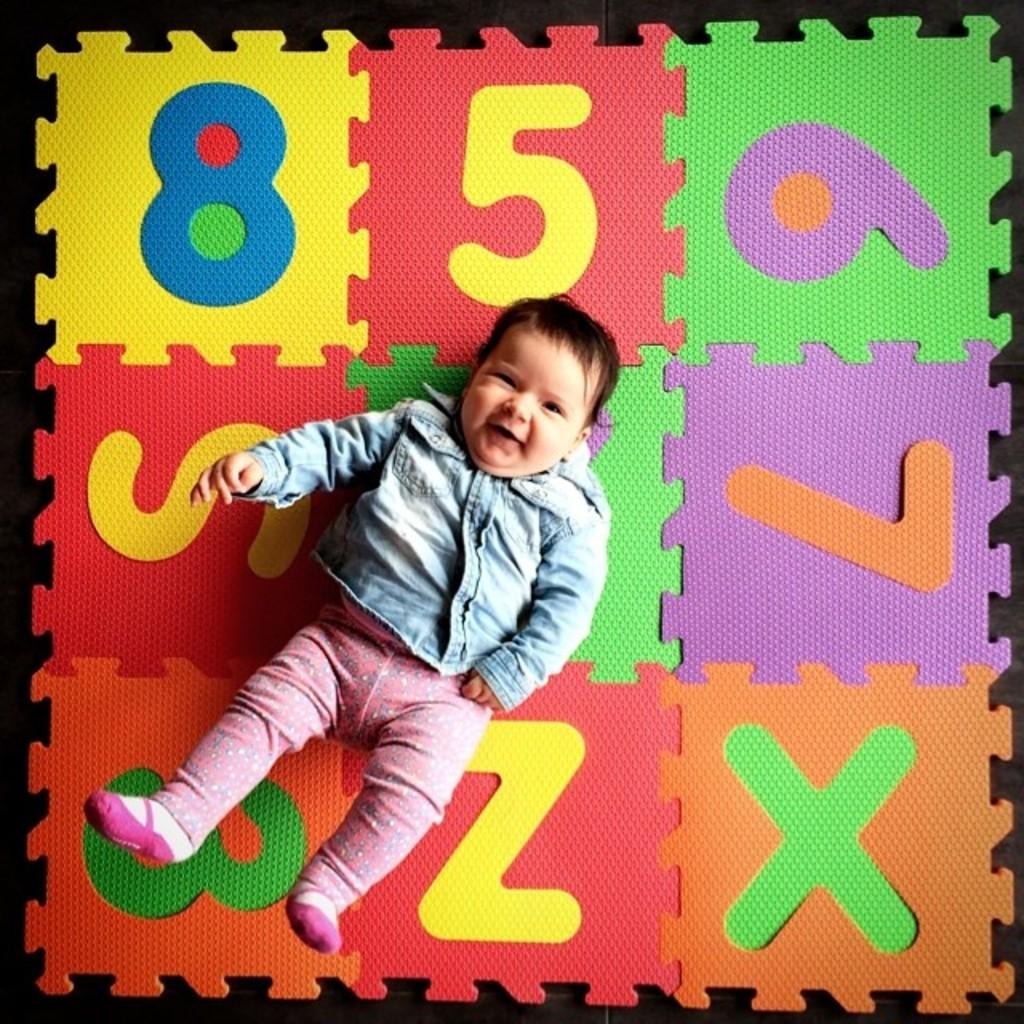What is the main object in the image? There is a numbers puzzle mat in the image. What is the baby doing on the mat? The baby is lying on the mat. How does the baby appear to be feeling? The baby is smiling. What type of fact can be seen in the image? There is no fact present in the image; it features a baby lying on a numbers puzzle mat. Can you tell me how many toes the baby has on their left foot? The image does not provide enough detail to determine the number of toes on the baby's left foot. 